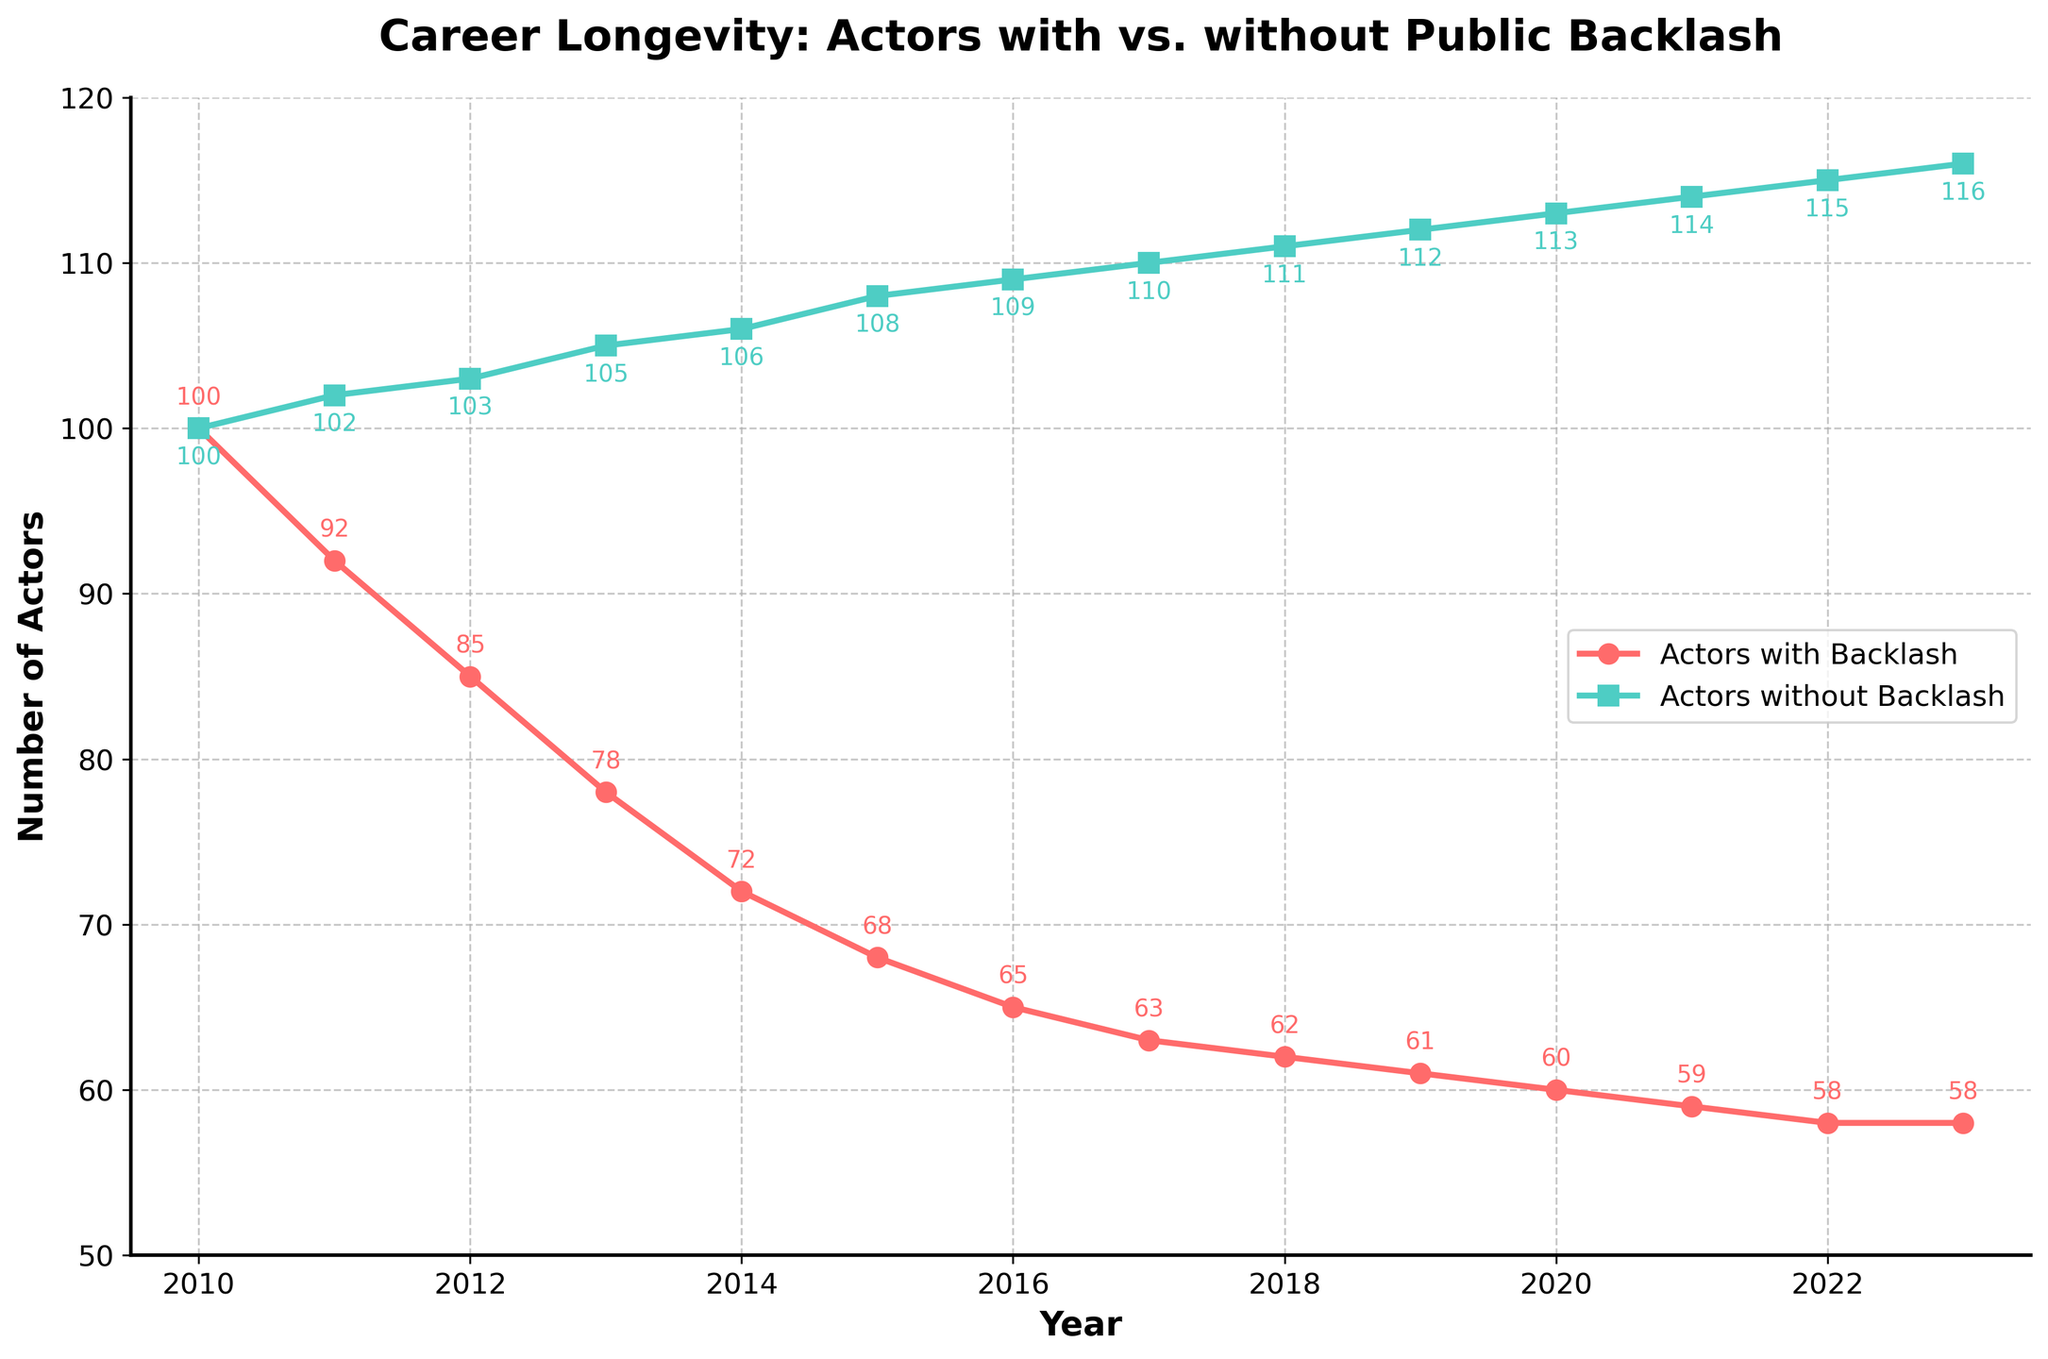How many actors with backlash remained in 2017? Look at the data point for the year 2017 under the "Actors with Backlash" line. The value is 63.
Answer: 63 In which year did the number of actors without backlash surpass 110? Check the data points for the "Actors without Backlash" line. The number first surpasses 110 in 2017.
Answer: 2017 What is the difference in the number of actors with backlash between 2011 and 2015? From the data, the number of actors with backlash in 2011 is 92 and in 2015 is 68. Subtract 68 from 92 to get the difference.
Answer: 24 What's the percentage decrease in the number of actors with backlash from 2010 to 2023? In 2010, there are 100 actors with backlash, and in 2023, there are 58. The decrease is 100 - 58 = 42. The percentage decrease is (42/100) * 100% = 42%.
Answer: 42% By how much did the number of actors without backlash increase from 2010 to 2023? The number of actors without backlash in 2010 is 100, and in 2023, it is 116. The increase is 116 - 100 = 16.
Answer: 16 Which group had a higher retention rate from 2010 to 2023? Compare the initial and final numbers for both groups. For actors with backlash, it's 100 to 58, a 58% retention rate. For actors without backlash, it's 100 to 116, a retention rate above 100%. The actors without backlash have a higher retention rate.
Answer: Actors without backlash At what rate did the number of actors with backlash drop each year from 2010 to 2014? In 2010, there were 100 actors with backlash, and in 2014, there were 72. The difference is 100 - 72 = 28 over 4 years, which is 28/4 = 7 actors per year.
Answer: 7 per year In which year is the number of actors without backlash exactly 111? Look for the year corresponding to the value 111 in the "Actors without Backlash" line. This is in 2018.
Answer: 2018 What is the ratio of actors with backlash to actors without backlash in 2023? In 2023, there are 58 actors with backlash and 116 without. The ratio is 58 to 116, which simplifies to 1:2.
Answer: 1:2 Which line is represented by square markers? Observe the plot and identify which line has squares. The line for "Actors without Backlash" is represented by square markers.
Answer: Actors without Backlash 